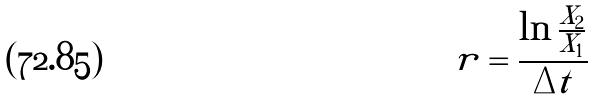<formula> <loc_0><loc_0><loc_500><loc_500>r = \frac { \ln \frac { X _ { 2 } } { X _ { 1 } } } { \Delta t }</formula> 